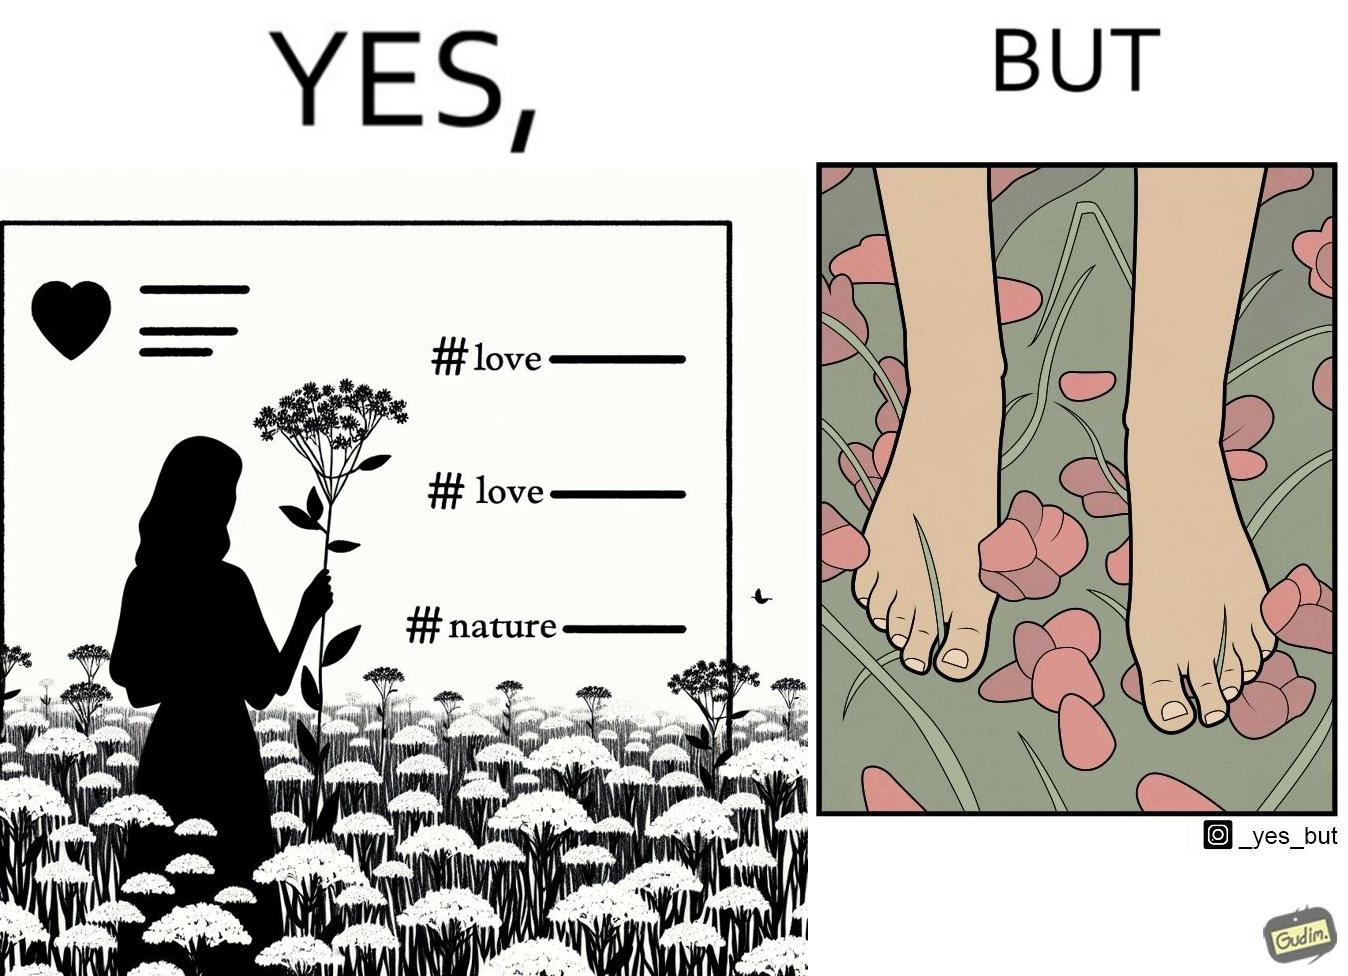Explain why this image is satirical. The image is ironical, as the social ,edia post shows the appreciation of nature, while an image of the feet on the ground stepping on the flower petals shows an unintentional disrespect of nature. 